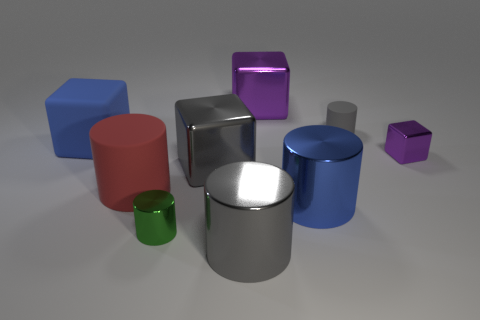How many other things are the same material as the big red cylinder? There are two other objects in the image that appear to be made of the same glossy material as the big red cylinder. These objects are the large silver cylinder and the small green cylinder. 